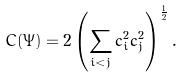<formula> <loc_0><loc_0><loc_500><loc_500>C ( \Psi ) = 2 \left ( \sum _ { i < j } c _ { i } ^ { 2 } c _ { j } ^ { 2 } \right ) ^ { \frac { 1 } { 2 } } .</formula> 